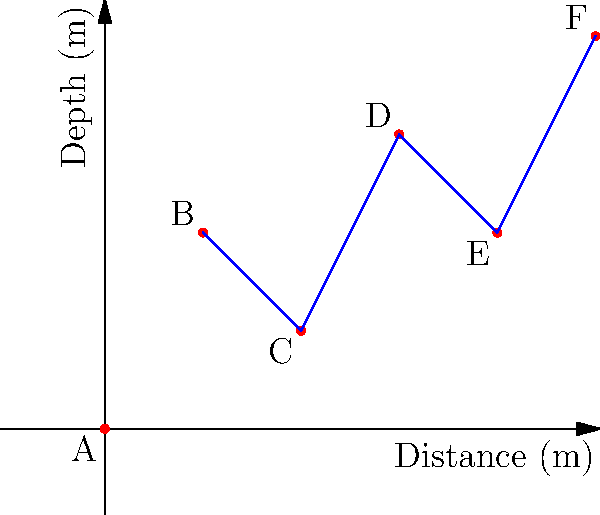The graph above represents a sonar profile of a submerged shipwreck site. Each point (A-F) represents a distinct feature of the wreck. Which feature is likely to be the highest point of the shipwreck, and what is its approximate depth? To determine the highest point of the shipwreck and its approximate depth, we need to analyze the graph step-by-step:

1. The y-axis represents depth, with lower values indicating shallower depths (closer to the water surface).
2. The x-axis represents distance along the sonar scan.
3. We need to identify the point with the lowest y-value, as this will be the shallowest (highest) point of the wreck.

Examining the points:
A: (0,0)
B: (1,2)
C: (2,1)
D: (3,3)
E: (4,2)
F: (5,4)

Point A has the lowest y-value at 0, making it the shallowest point. However, this is likely the starting point of the scan and may not represent a part of the wreck.

Among the other points, Point C has the lowest y-value at 1, indicating it is the shallowest (highest) point of the actual wreck structure.

Therefore, Point C, with a depth of approximately 1 meter, is likely to be the highest point of the shipwreck.
Answer: Point C, 1 meter deep 